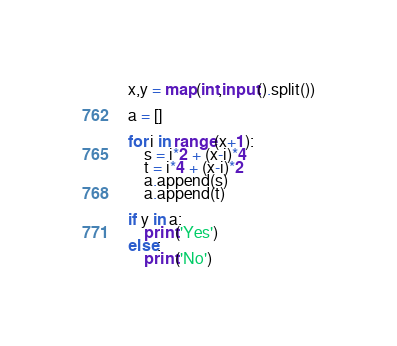<code> <loc_0><loc_0><loc_500><loc_500><_Python_>x,y = map(int,input().split())

a = []

for i in range(x+1):
    s = i*2 + (x-i)*4
    t = i*4 + (x-i)*2
    a.append(s)
    a.append(t)
    
if y in a:
    print('Yes')
else:
    print('No')
</code> 